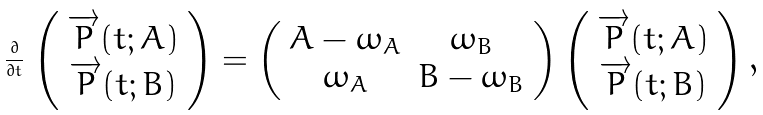<formula> <loc_0><loc_0><loc_500><loc_500>\frac { \partial } { \partial t } \begin{array} { c c } \left ( \begin{array} { c } \overrightarrow { P } ( t ; A ) \\ \overrightarrow { P } ( t ; B ) \\ \end{array} \right ) = \left ( \begin{array} { c c } A - \omega _ { A } & \omega _ { B } \\ \omega _ { A } & B - \omega _ { B } \\ \end{array} \right ) \left ( \begin{array} { c } \overrightarrow { P } ( t ; A ) \\ \overrightarrow { P } ( t ; B ) \\ \end{array} \right ) , \end{array}</formula> 